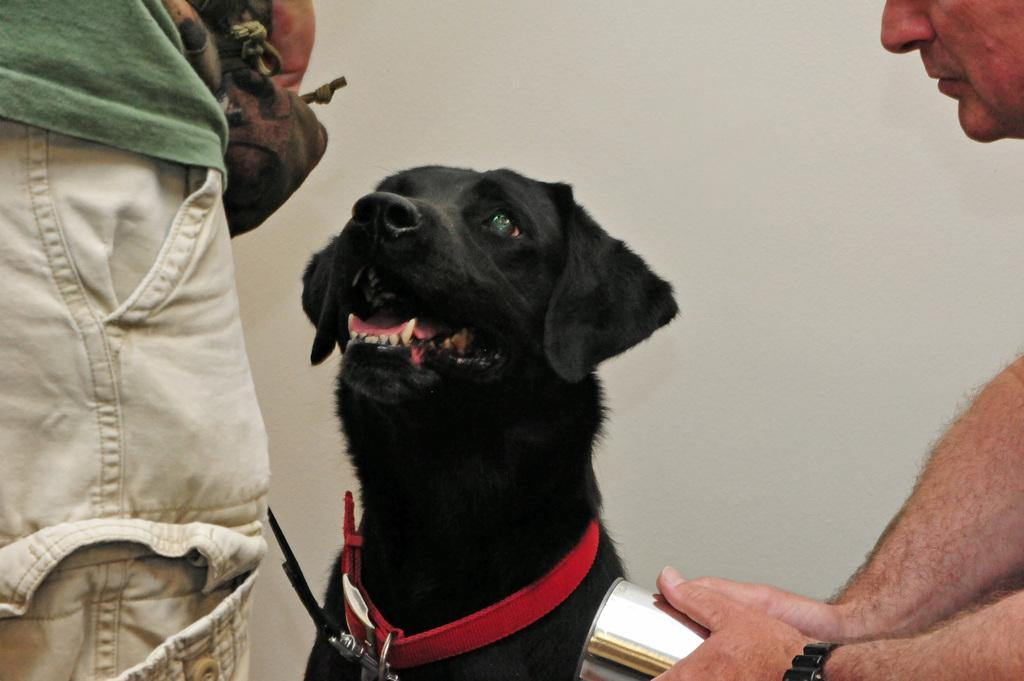How many people are present in the image? There are two persons in the image. What other living creature can be seen in the image? There is a dog in the image. What month is depicted in the image? There is no indication of a specific month in the image. Is the image based on a fictional story? There is no information to suggest that the image is based on a fictional story. 